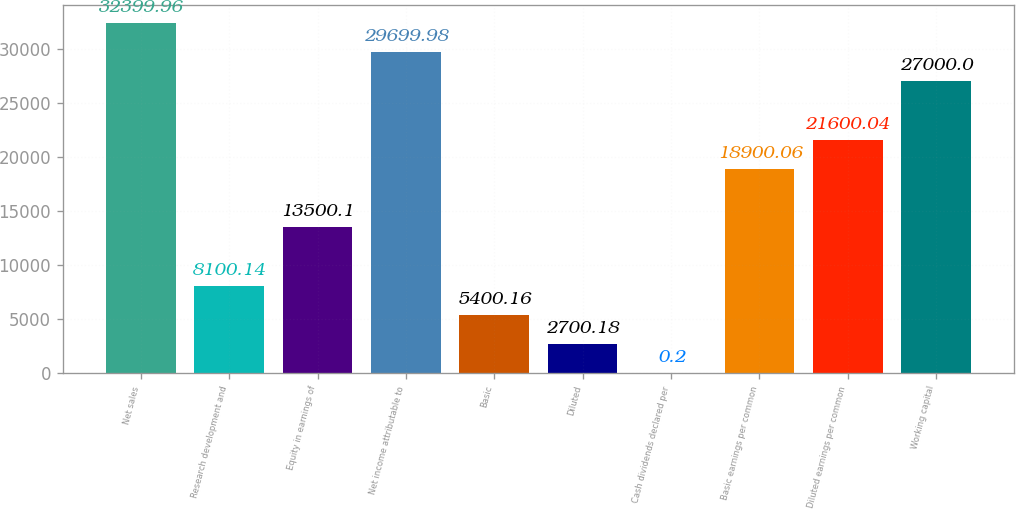<chart> <loc_0><loc_0><loc_500><loc_500><bar_chart><fcel>Net sales<fcel>Research development and<fcel>Equity in earnings of<fcel>Net income attributable to<fcel>Basic<fcel>Diluted<fcel>Cash dividends declared per<fcel>Basic earnings per common<fcel>Diluted earnings per common<fcel>Working capital<nl><fcel>32400<fcel>8100.14<fcel>13500.1<fcel>29700<fcel>5400.16<fcel>2700.18<fcel>0.2<fcel>18900.1<fcel>21600<fcel>27000<nl></chart> 